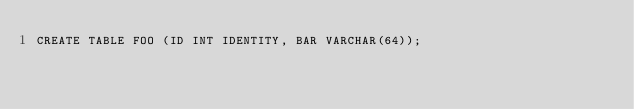Convert code to text. <code><loc_0><loc_0><loc_500><loc_500><_SQL_>CREATE TABLE FOO (ID INT IDENTITY, BAR VARCHAR(64));
</code> 